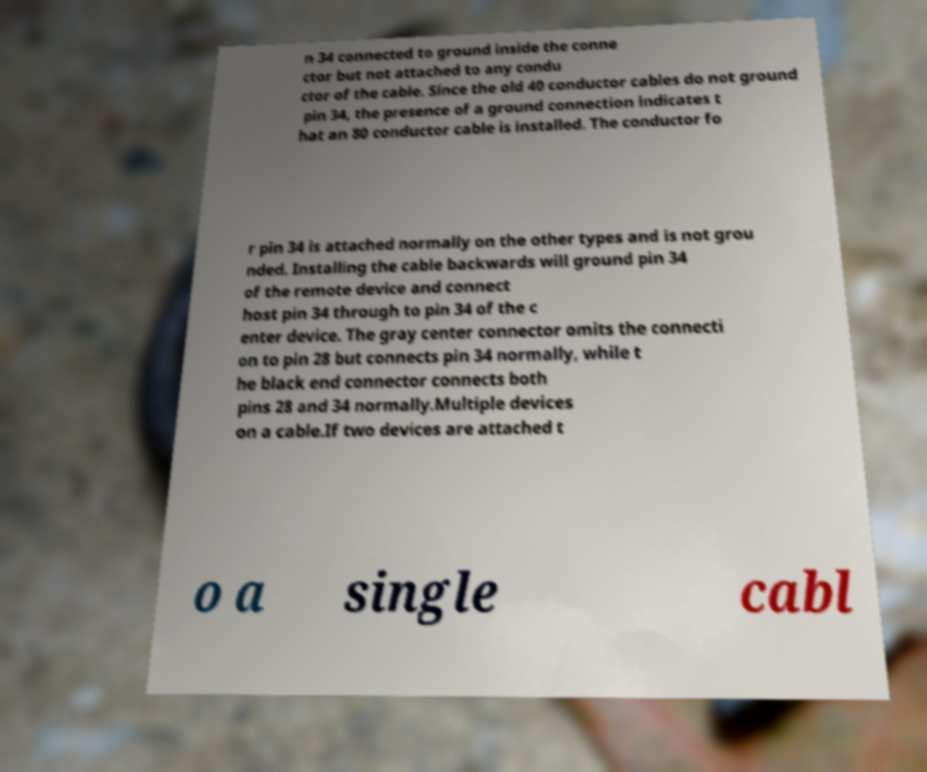I need the written content from this picture converted into text. Can you do that? n 34 connected to ground inside the conne ctor but not attached to any condu ctor of the cable. Since the old 40 conductor cables do not ground pin 34, the presence of a ground connection indicates t hat an 80 conductor cable is installed. The conductor fo r pin 34 is attached normally on the other types and is not grou nded. Installing the cable backwards will ground pin 34 of the remote device and connect host pin 34 through to pin 34 of the c enter device. The gray center connector omits the connecti on to pin 28 but connects pin 34 normally, while t he black end connector connects both pins 28 and 34 normally.Multiple devices on a cable.If two devices are attached t o a single cabl 